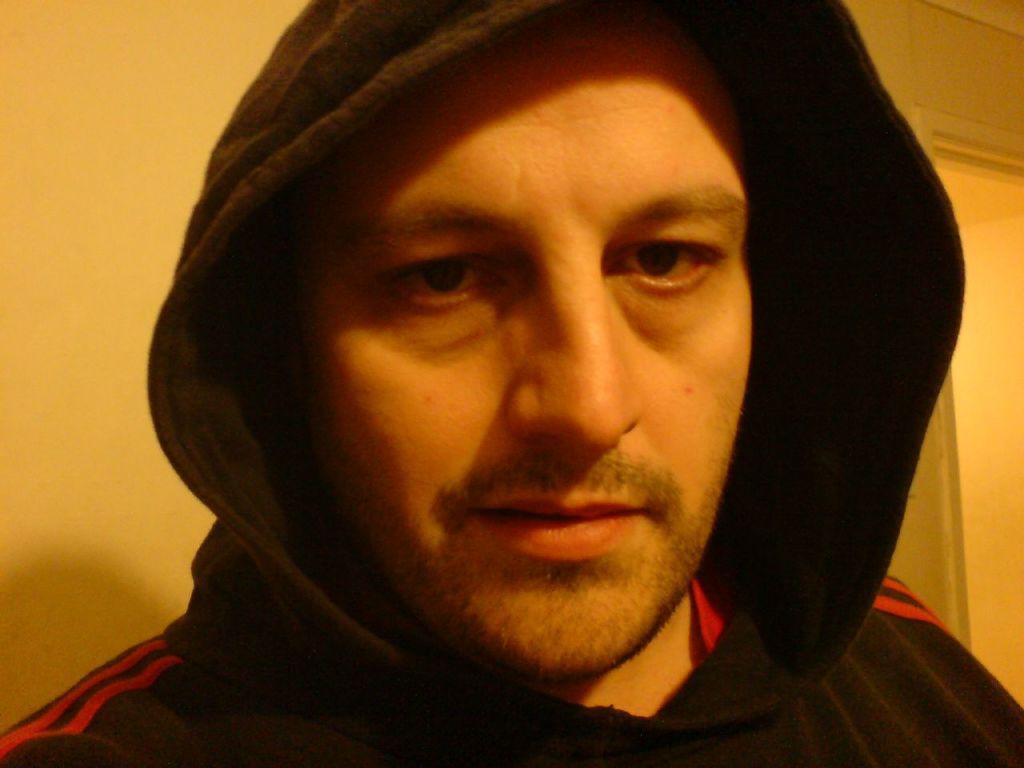How would you summarize this image in a sentence or two? In this image there is a person, behind the person there is a wall. 